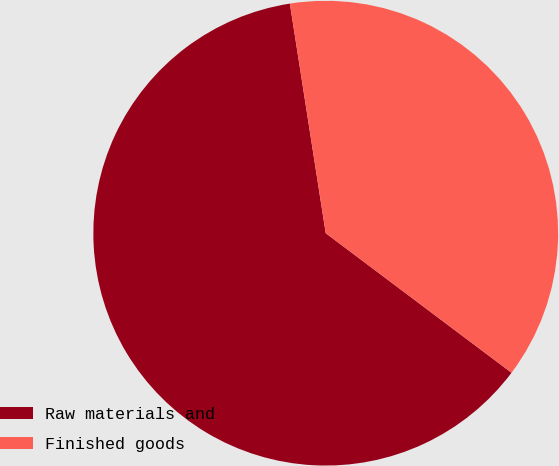Convert chart to OTSL. <chart><loc_0><loc_0><loc_500><loc_500><pie_chart><fcel>Raw materials and<fcel>Finished goods<nl><fcel>62.28%<fcel>37.72%<nl></chart> 